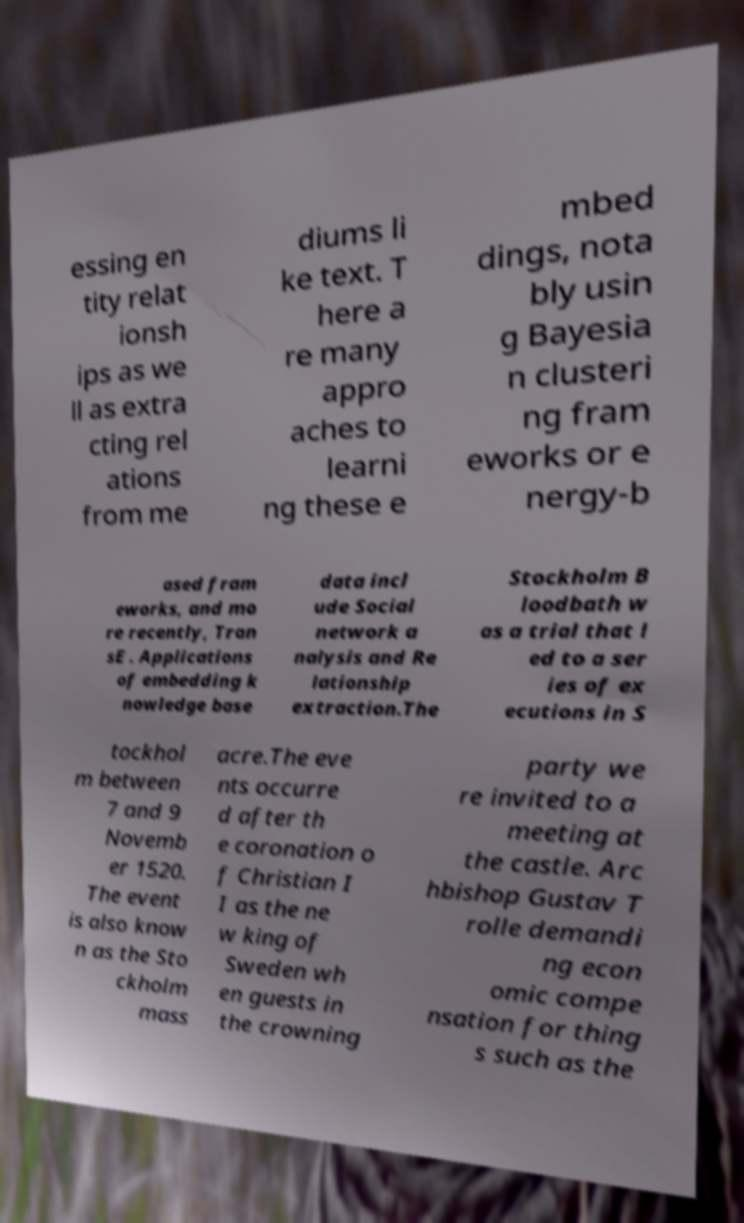Can you accurately transcribe the text from the provided image for me? essing en tity relat ionsh ips as we ll as extra cting rel ations from me diums li ke text. T here a re many appro aches to learni ng these e mbed dings, nota bly usin g Bayesia n clusteri ng fram eworks or e nergy-b ased fram eworks, and mo re recently, Tran sE . Applications of embedding k nowledge base data incl ude Social network a nalysis and Re lationship extraction.The Stockholm B loodbath w as a trial that l ed to a ser ies of ex ecutions in S tockhol m between 7 and 9 Novemb er 1520. The event is also know n as the Sto ckholm mass acre.The eve nts occurre d after th e coronation o f Christian I I as the ne w king of Sweden wh en guests in the crowning party we re invited to a meeting at the castle. Arc hbishop Gustav T rolle demandi ng econ omic compe nsation for thing s such as the 